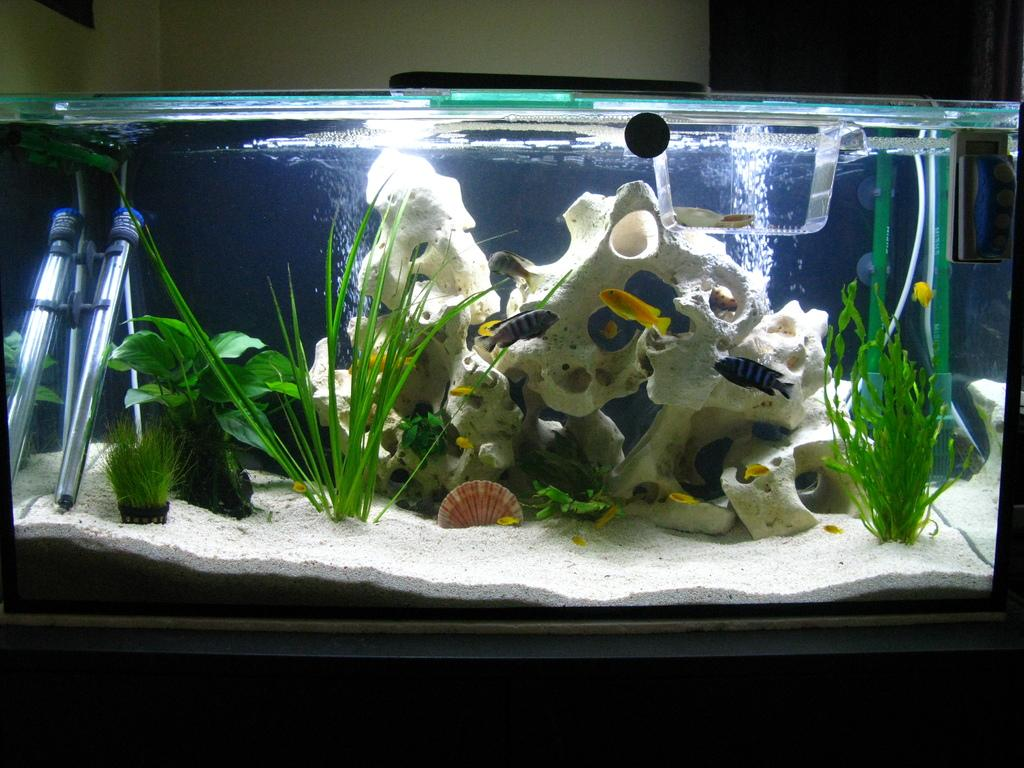What is the main subject of the picture? The main subject of the picture is an aquarium. What can be found inside the aquarium? The aquarium contains a stand, a plant, a leaf, fishes, water, and a white object. What is the purpose of the stand inside the aquarium? The stand provides support for the plant and other objects in the aquarium. What type of plant is present in the aquarium? The type of plant in the aquarium is not specified in the facts. How many fishes are visible in the aquarium? The number of fishes in the aquarium is not specified in the facts. What is the color of the water in the aquarium? The color of the water in the aquarium is not specified in the facts. What is the white object in the aquarium? The white object in the aquarium is not specified in the facts. What is visible on the top of the picture? A wall is visible on the top of the picture. What is visible on the bottom of the picture? A table is visible on the bottom of the picture. What type of pleasure can be seen on the faces of the fishes in the image? There is no indication of the fishes' emotions or expressions in the image, so it cannot be determined if they are experiencing pleasure. 